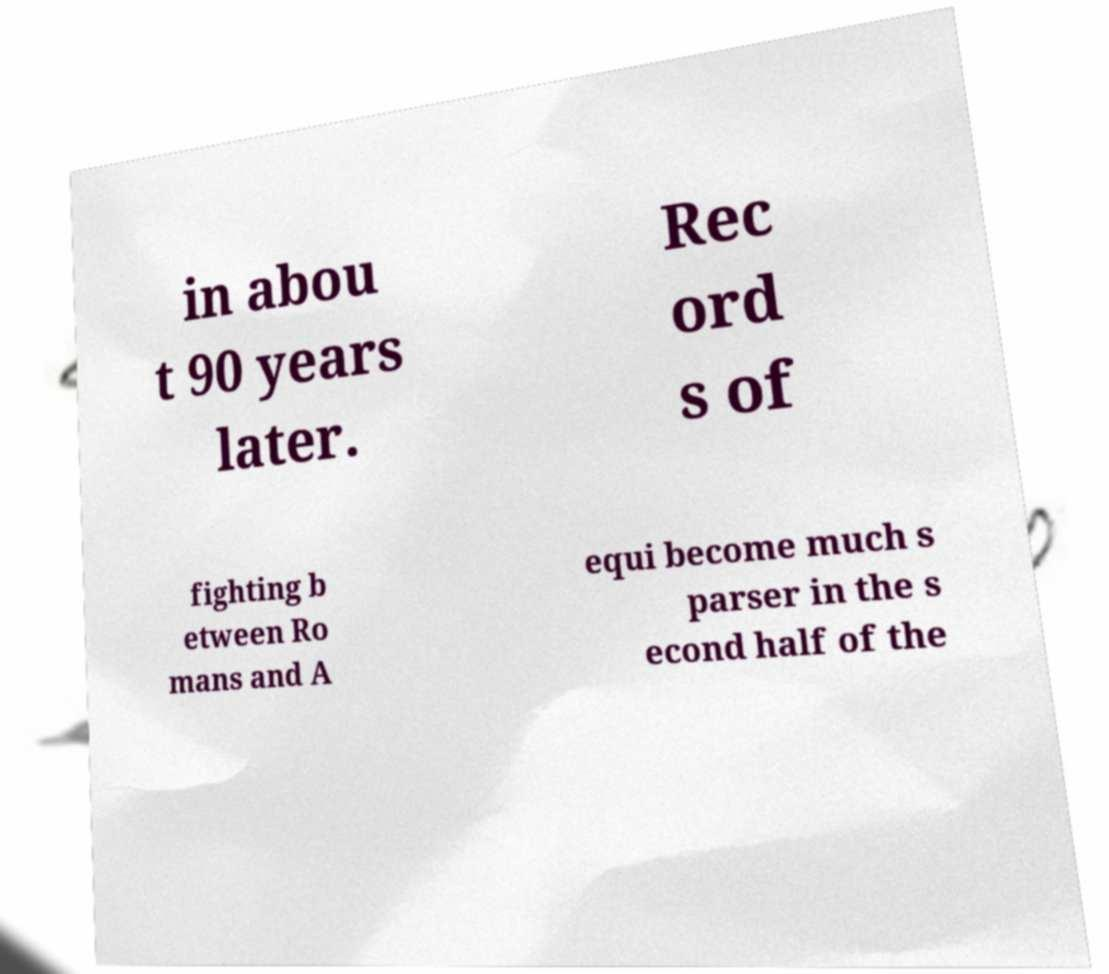Can you accurately transcribe the text from the provided image for me? in abou t 90 years later. Rec ord s of fighting b etween Ro mans and A equi become much s parser in the s econd half of the 